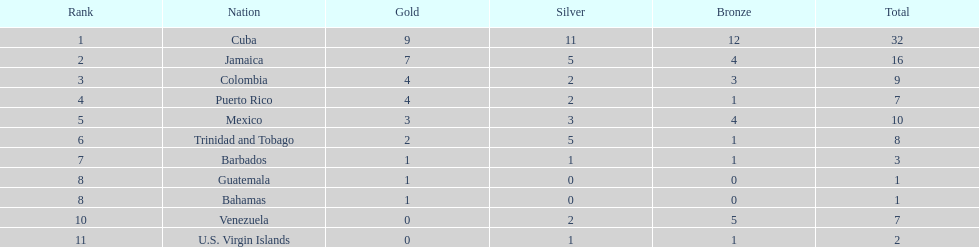The nation before mexico in the table Puerto Rico. 